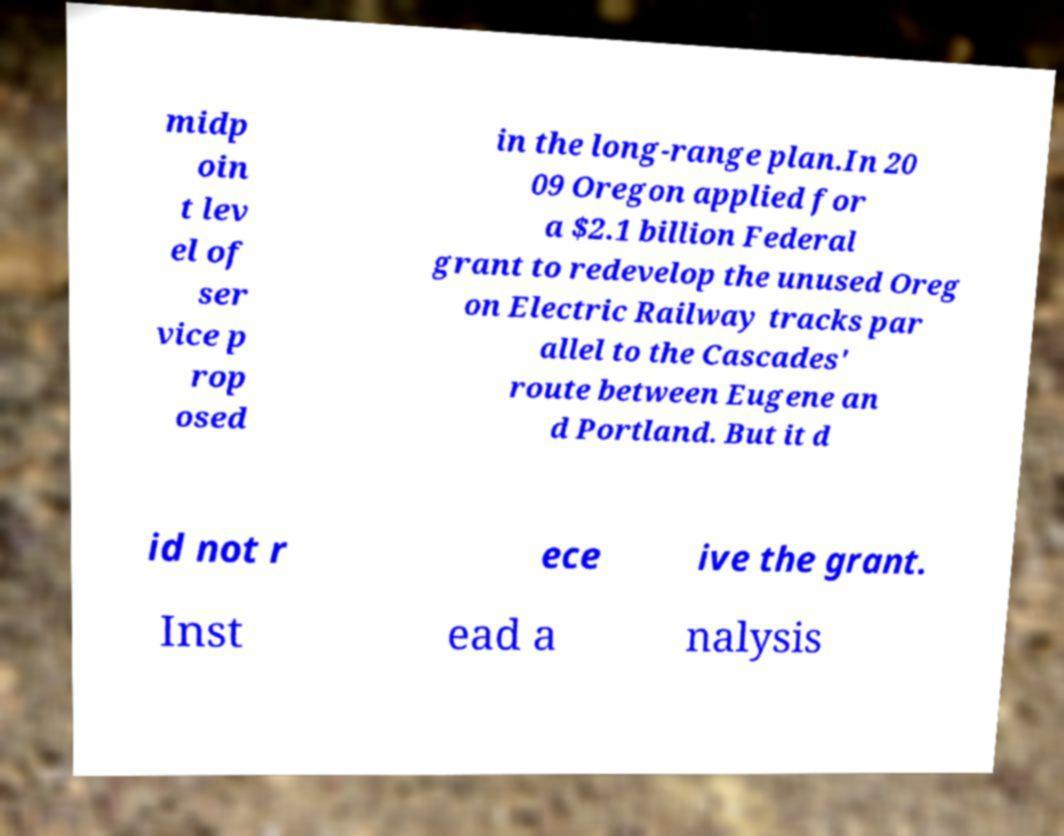Please read and relay the text visible in this image. What does it say? midp oin t lev el of ser vice p rop osed in the long-range plan.In 20 09 Oregon applied for a $2.1 billion Federal grant to redevelop the unused Oreg on Electric Railway tracks par allel to the Cascades' route between Eugene an d Portland. But it d id not r ece ive the grant. Inst ead a nalysis 